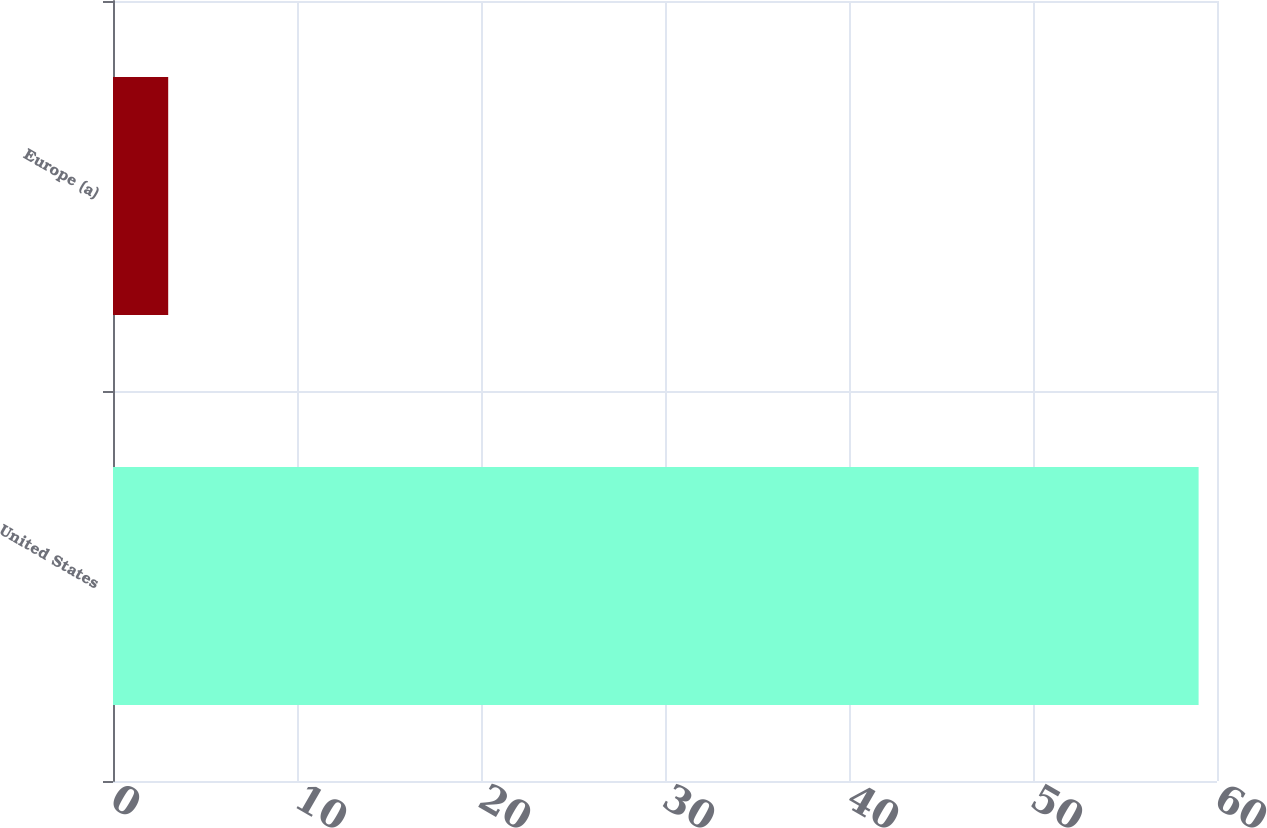Convert chart to OTSL. <chart><loc_0><loc_0><loc_500><loc_500><bar_chart><fcel>United States<fcel>Europe (a)<nl><fcel>59<fcel>3<nl></chart> 